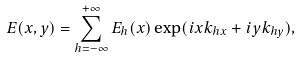<formula> <loc_0><loc_0><loc_500><loc_500>E ( x , y ) = \sum _ { h = - \infty } ^ { + \infty } E _ { h } ( x ) \exp ( i x k _ { h x } + i y k _ { h y } ) ,</formula> 